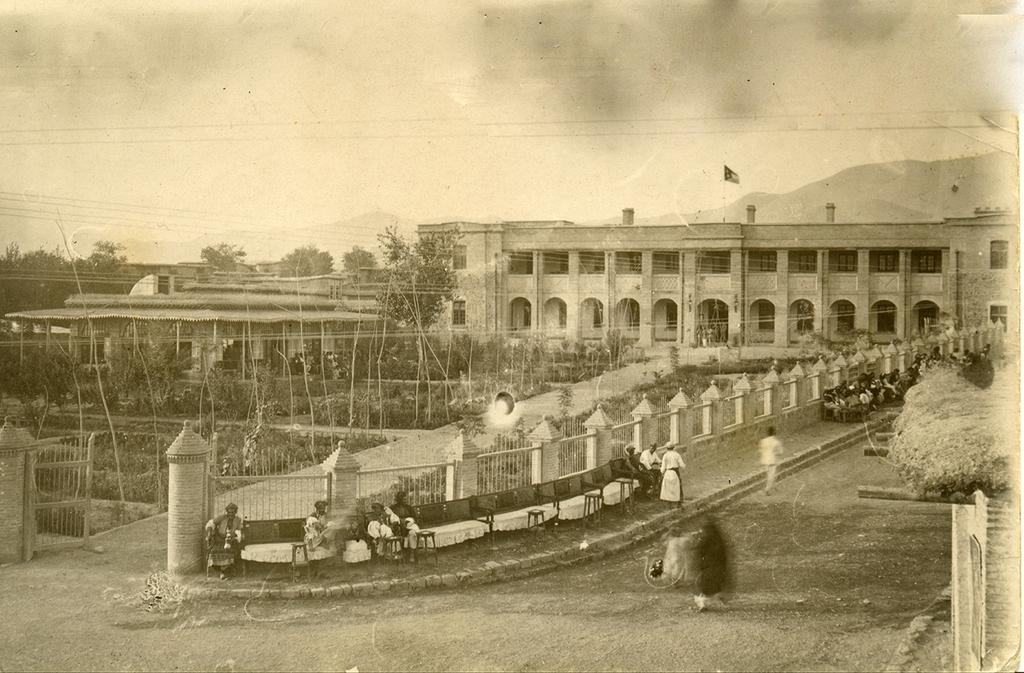How would you summarize this image in a sentence or two? In this picture i think it is a black and white picture and we can see some building and on building flag with the pole and in front of the building there are so many trees and a way to that building and here the gate and aside to this wall fence they are chairs and people are sitting and here it is a road and above building we have sky. 